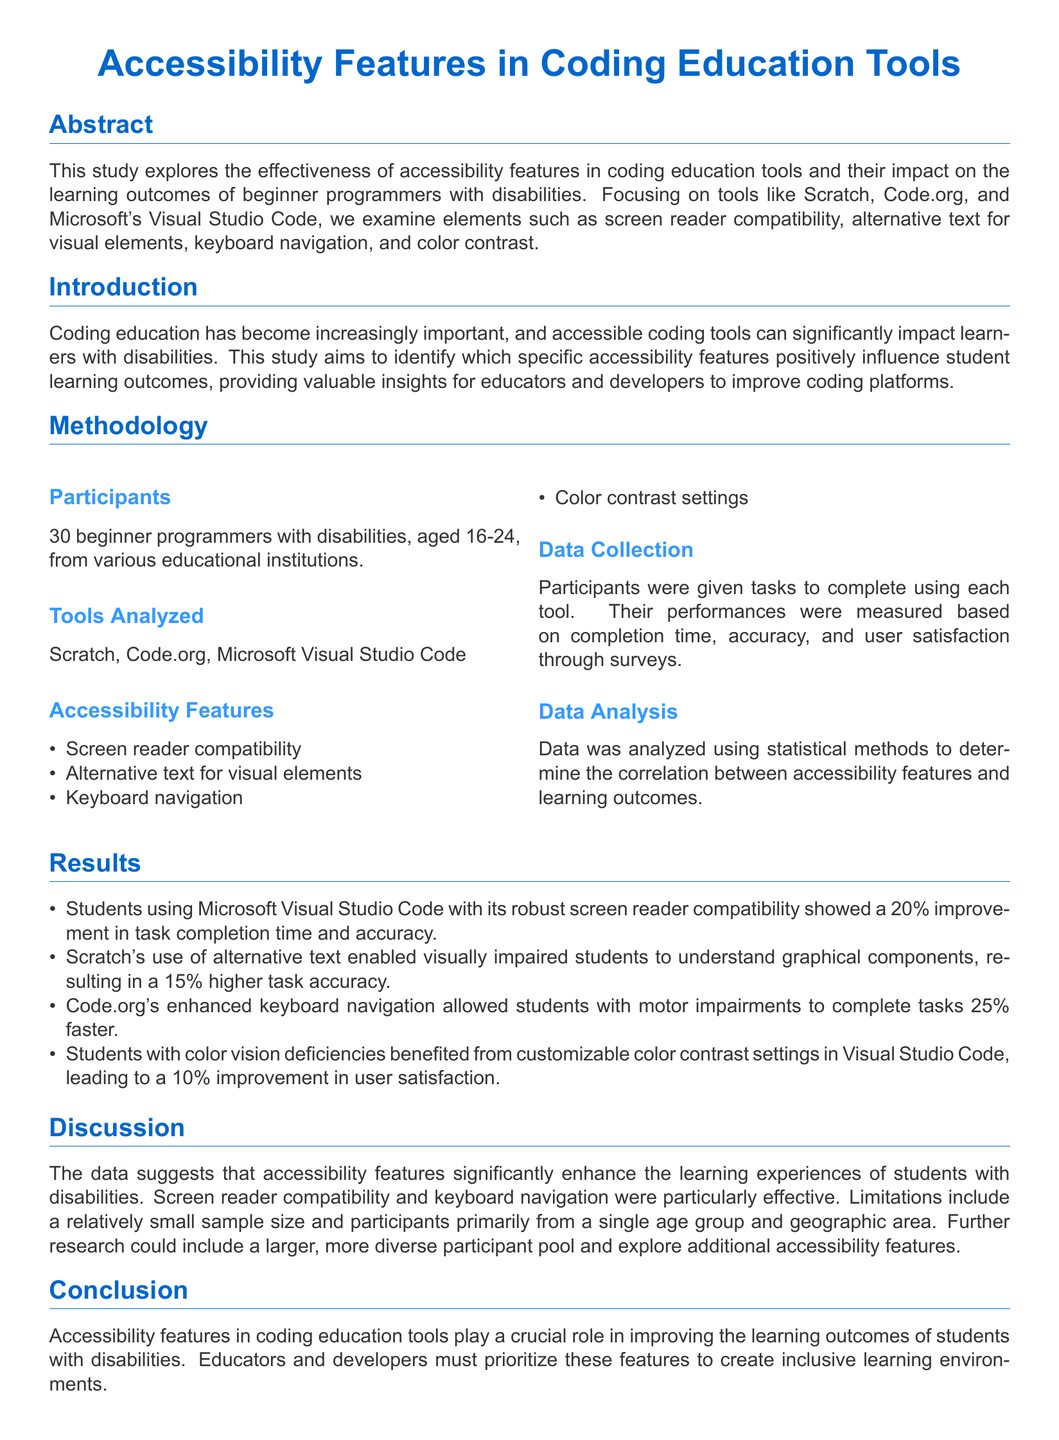What is the age range of participants? The participants in the study are stated to be aged 16-24.
Answer: 16-24 How many tools were analyzed in the study? The study mentions analyzing three specific tools: Scratch, Code.org, and Microsoft Visual Studio Code.
Answer: 3 Which coding tool showed a 20% improvement in task completion time and accuracy? The results section indicates that Microsoft Visual Studio Code showed this improvement due to its screen reader compatibility.
Answer: Microsoft Visual Studio Code What specific accessibility feature in Scratch helped visually impaired students? Alternative text for visual elements in Scratch enabled visually impaired students to understand graphical components.
Answer: Alternative text What percentage improvement in user satisfaction did students with color vision deficiencies experience with Visual Studio Code? The document states that these students experienced a 10% improvement in user satisfaction due to customizable color contrast settings.
Answer: 10% What was one of the limitations mentioned in the discussion? The discussion highlights a limitation related to the small sample size and the demographic of participants being primarily from a single age group and geographic area.
Answer: Small sample size 